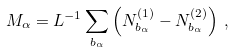<formula> <loc_0><loc_0><loc_500><loc_500>M _ { \alpha } = L ^ { - 1 } \sum _ { b _ { \alpha } } \left ( N _ { b _ { \alpha } } ^ { ( 1 ) } - N _ { b _ { \alpha } } ^ { ( 2 ) } \right ) \, ,</formula> 